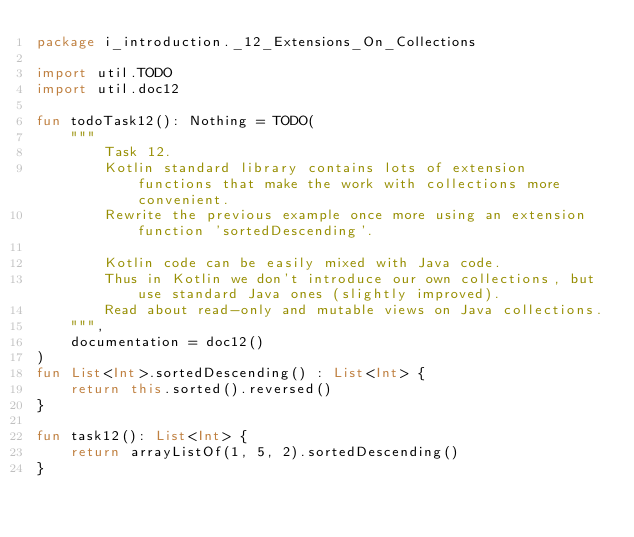<code> <loc_0><loc_0><loc_500><loc_500><_Kotlin_>package i_introduction._12_Extensions_On_Collections

import util.TODO
import util.doc12

fun todoTask12(): Nothing = TODO(
    """
        Task 12.
        Kotlin standard library contains lots of extension functions that make the work with collections more convenient.
        Rewrite the previous example once more using an extension function 'sortedDescending'.

        Kotlin code can be easily mixed with Java code.
        Thus in Kotlin we don't introduce our own collections, but use standard Java ones (slightly improved).
        Read about read-only and mutable views on Java collections.
    """,
    documentation = doc12()
)
fun List<Int>.sortedDescending() : List<Int> {
    return this.sorted().reversed()
}

fun task12(): List<Int> {
    return arrayListOf(1, 5, 2).sortedDescending()
}

</code> 